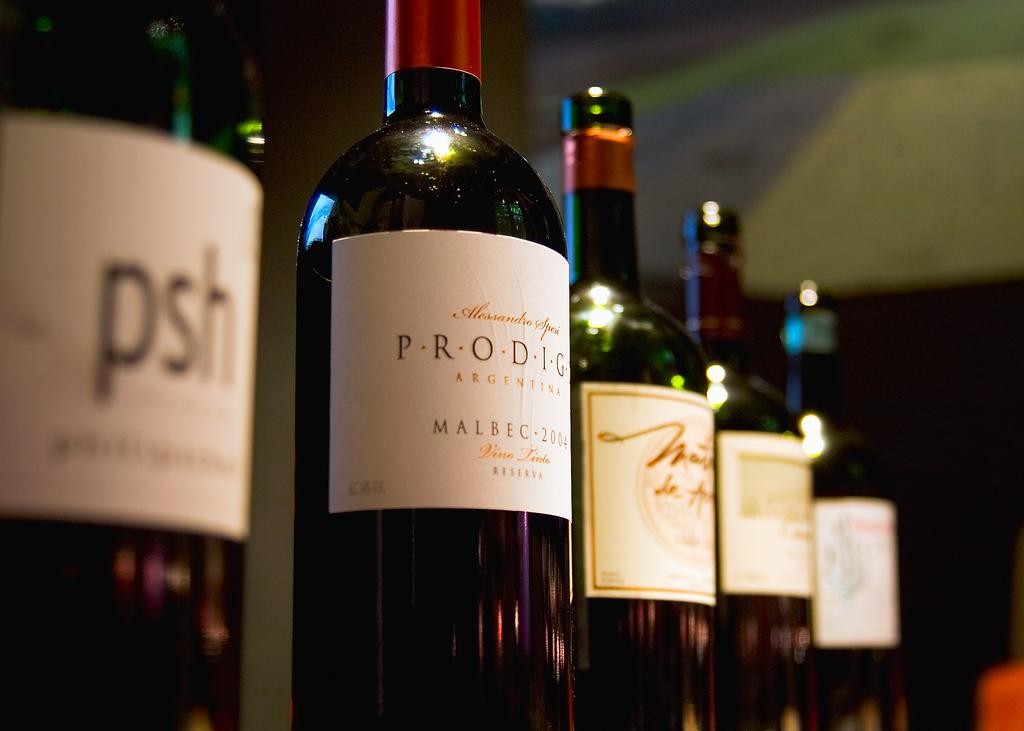<image>
Describe the image concisely. Several bottles of red win, one of which has the label Malbec. 